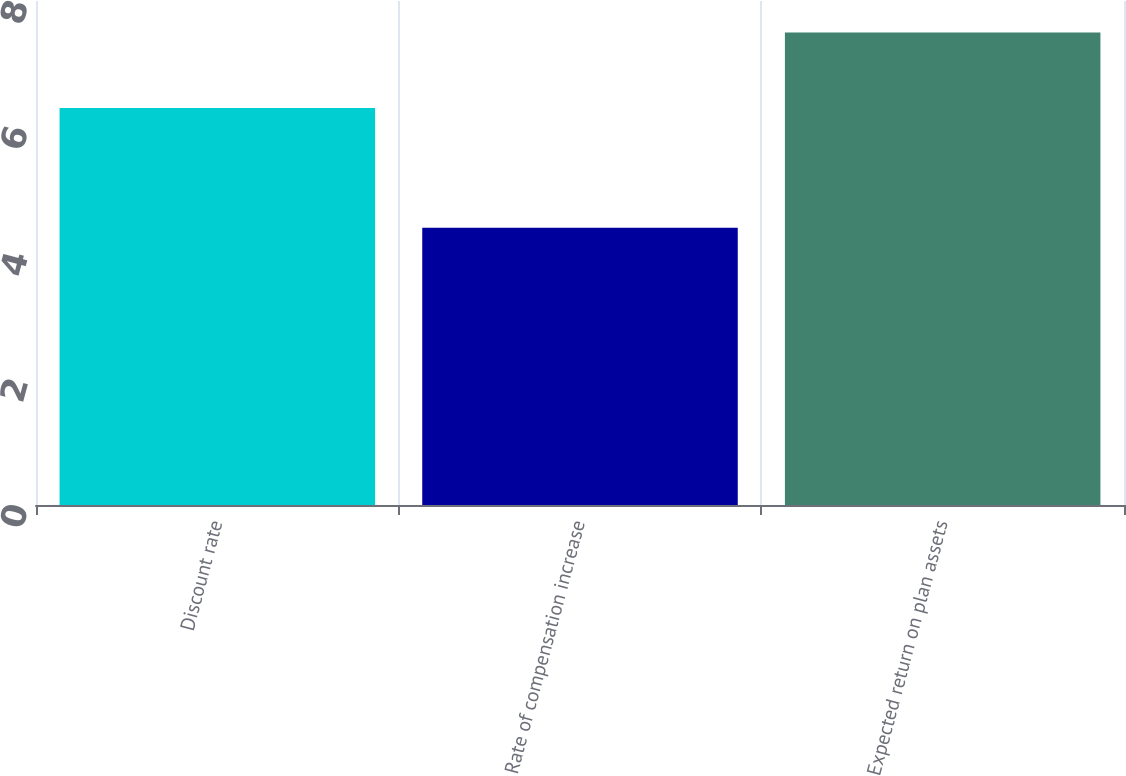Convert chart. <chart><loc_0><loc_0><loc_500><loc_500><bar_chart><fcel>Discount rate<fcel>Rate of compensation increase<fcel>Expected return on plan assets<nl><fcel>6.3<fcel>4.4<fcel>7.5<nl></chart> 